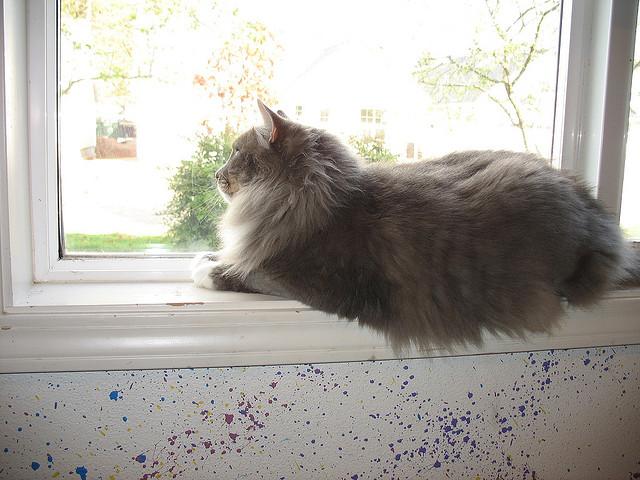How many windows?
Be succinct. 1. Is the cat happy?
Answer briefly. Yes. What is the cat laying on?
Quick response, please. Window sill. Is this a short haired cat?
Short answer required. No. Are these cats in the sun?
Concise answer only. Yes. What is under the cat?
Concise answer only. Windowsill. What is on the window?
Answer briefly. Cat. 